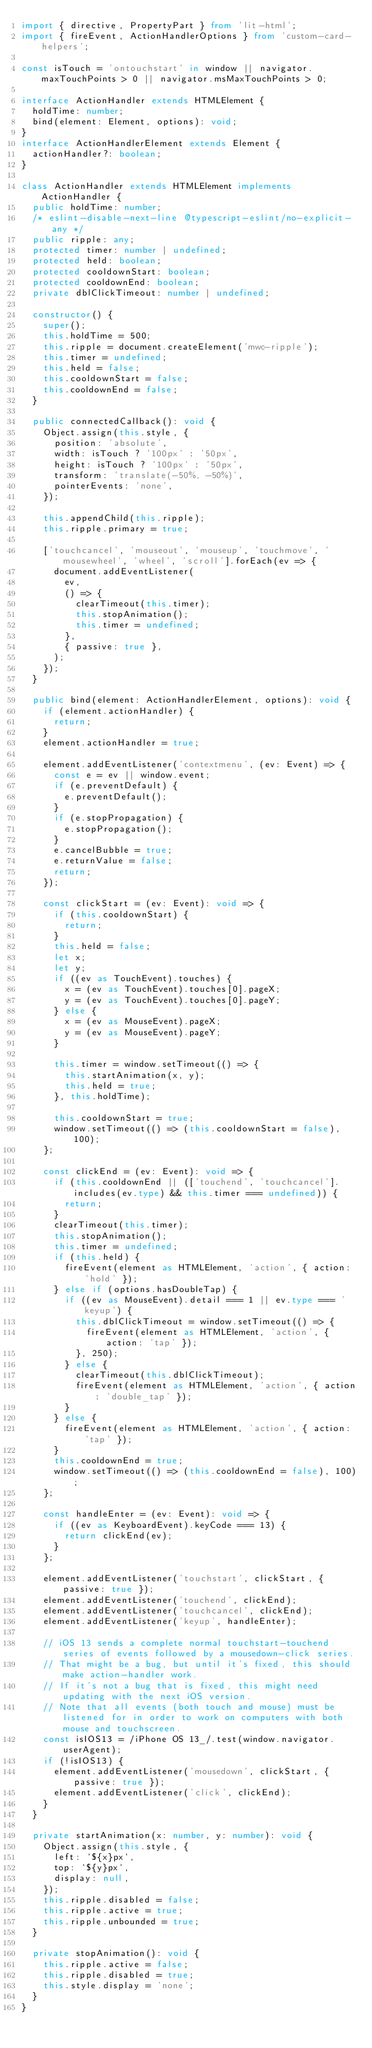Convert code to text. <code><loc_0><loc_0><loc_500><loc_500><_TypeScript_>import { directive, PropertyPart } from 'lit-html';
import { fireEvent, ActionHandlerOptions } from 'custom-card-helpers';

const isTouch = 'ontouchstart' in window || navigator.maxTouchPoints > 0 || navigator.msMaxTouchPoints > 0;

interface ActionHandler extends HTMLElement {
  holdTime: number;
  bind(element: Element, options): void;
}
interface ActionHandlerElement extends Element {
  actionHandler?: boolean;
}

class ActionHandler extends HTMLElement implements ActionHandler {
  public holdTime: number;
  /* eslint-disable-next-line @typescript-eslint/no-explicit-any */
  public ripple: any;
  protected timer: number | undefined;
  protected held: boolean;
  protected cooldownStart: boolean;
  protected cooldownEnd: boolean;
  private dblClickTimeout: number | undefined;

  constructor() {
    super();
    this.holdTime = 500;
    this.ripple = document.createElement('mwc-ripple');
    this.timer = undefined;
    this.held = false;
    this.cooldownStart = false;
    this.cooldownEnd = false;
  }

  public connectedCallback(): void {
    Object.assign(this.style, {
      position: 'absolute',
      width: isTouch ? '100px' : '50px',
      height: isTouch ? '100px' : '50px',
      transform: 'translate(-50%, -50%)',
      pointerEvents: 'none',
    });

    this.appendChild(this.ripple);
    this.ripple.primary = true;

    ['touchcancel', 'mouseout', 'mouseup', 'touchmove', 'mousewheel', 'wheel', 'scroll'].forEach(ev => {
      document.addEventListener(
        ev,
        () => {
          clearTimeout(this.timer);
          this.stopAnimation();
          this.timer = undefined;
        },
        { passive: true },
      );
    });
  }

  public bind(element: ActionHandlerElement, options): void {
    if (element.actionHandler) {
      return;
    }
    element.actionHandler = true;

    element.addEventListener('contextmenu', (ev: Event) => {
      const e = ev || window.event;
      if (e.preventDefault) {
        e.preventDefault();
      }
      if (e.stopPropagation) {
        e.stopPropagation();
      }
      e.cancelBubble = true;
      e.returnValue = false;
      return;
    });

    const clickStart = (ev: Event): void => {
      if (this.cooldownStart) {
        return;
      }
      this.held = false;
      let x;
      let y;
      if ((ev as TouchEvent).touches) {
        x = (ev as TouchEvent).touches[0].pageX;
        y = (ev as TouchEvent).touches[0].pageY;
      } else {
        x = (ev as MouseEvent).pageX;
        y = (ev as MouseEvent).pageY;
      }

      this.timer = window.setTimeout(() => {
        this.startAnimation(x, y);
        this.held = true;
      }, this.holdTime);

      this.cooldownStart = true;
      window.setTimeout(() => (this.cooldownStart = false), 100);
    };

    const clickEnd = (ev: Event): void => {
      if (this.cooldownEnd || (['touchend', 'touchcancel'].includes(ev.type) && this.timer === undefined)) {
        return;
      }
      clearTimeout(this.timer);
      this.stopAnimation();
      this.timer = undefined;
      if (this.held) {
        fireEvent(element as HTMLElement, 'action', { action: 'hold' });
      } else if (options.hasDoubleTap) {
        if ((ev as MouseEvent).detail === 1 || ev.type === 'keyup') {
          this.dblClickTimeout = window.setTimeout(() => {
            fireEvent(element as HTMLElement, 'action', { action: 'tap' });
          }, 250);
        } else {
          clearTimeout(this.dblClickTimeout);
          fireEvent(element as HTMLElement, 'action', { action: 'double_tap' });
        }
      } else {
        fireEvent(element as HTMLElement, 'action', { action: 'tap' });
      }
      this.cooldownEnd = true;
      window.setTimeout(() => (this.cooldownEnd = false), 100);
    };

    const handleEnter = (ev: Event): void => {
      if ((ev as KeyboardEvent).keyCode === 13) {
        return clickEnd(ev);
      }
    };

    element.addEventListener('touchstart', clickStart, { passive: true });
    element.addEventListener('touchend', clickEnd);
    element.addEventListener('touchcancel', clickEnd);
    element.addEventListener('keyup', handleEnter);

    // iOS 13 sends a complete normal touchstart-touchend series of events followed by a mousedown-click series.
    // That might be a bug, but until it's fixed, this should make action-handler work.
    // If it's not a bug that is fixed, this might need updating with the next iOS version.
    // Note that all events (both touch and mouse) must be listened for in order to work on computers with both mouse and touchscreen.
    const isIOS13 = /iPhone OS 13_/.test(window.navigator.userAgent);
    if (!isIOS13) {
      element.addEventListener('mousedown', clickStart, { passive: true });
      element.addEventListener('click', clickEnd);
    }
  }

  private startAnimation(x: number, y: number): void {
    Object.assign(this.style, {
      left: `${x}px`,
      top: `${y}px`,
      display: null,
    });
    this.ripple.disabled = false;
    this.ripple.active = true;
    this.ripple.unbounded = true;
  }

  private stopAnimation(): void {
    this.ripple.active = false;
    this.ripple.disabled = true;
    this.style.display = 'none';
  }
}
</code> 